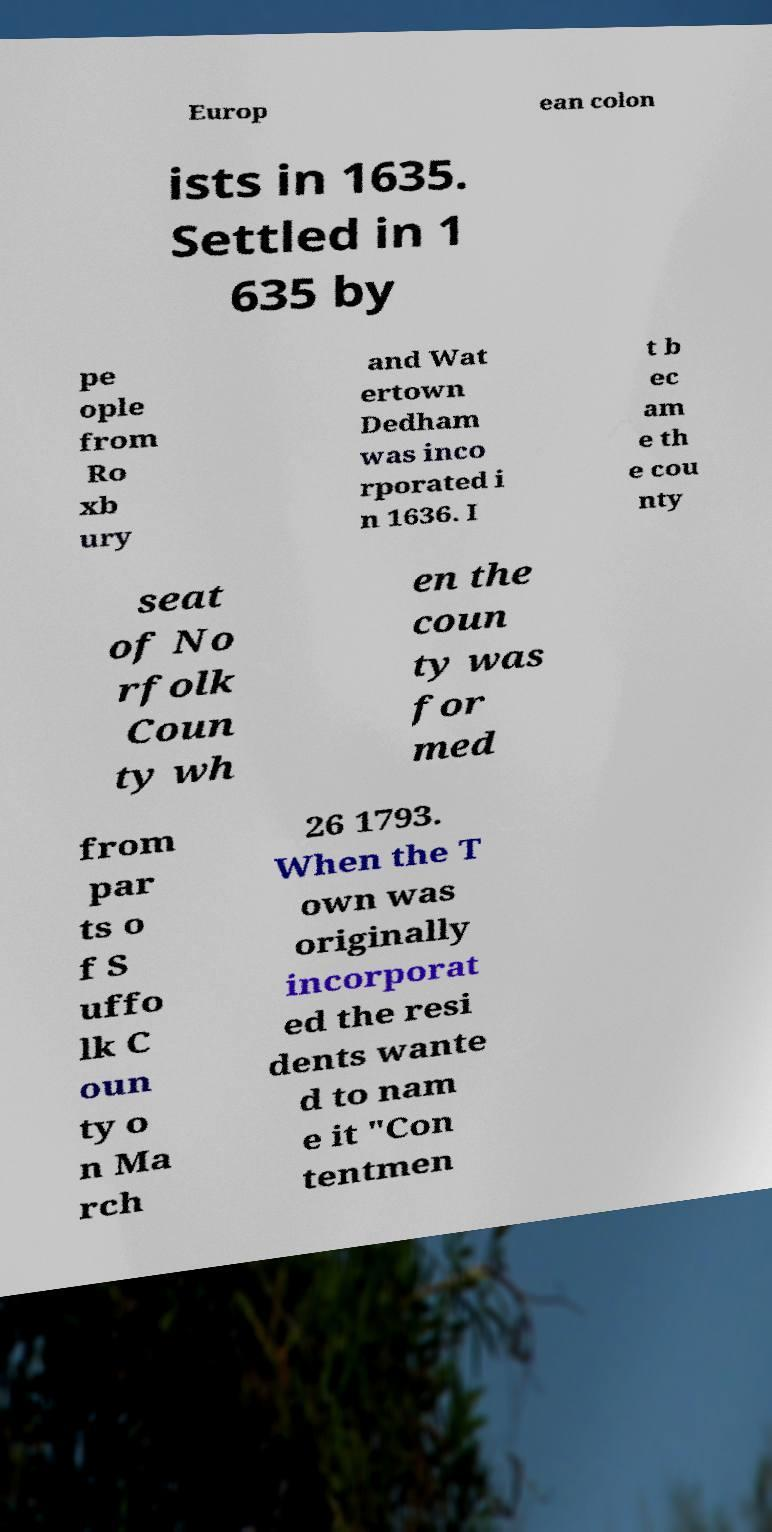For documentation purposes, I need the text within this image transcribed. Could you provide that? Europ ean colon ists in 1635. Settled in 1 635 by pe ople from Ro xb ury and Wat ertown Dedham was inco rporated i n 1636. I t b ec am e th e cou nty seat of No rfolk Coun ty wh en the coun ty was for med from par ts o f S uffo lk C oun ty o n Ma rch 26 1793. When the T own was originally incorporat ed the resi dents wante d to nam e it "Con tentmen 